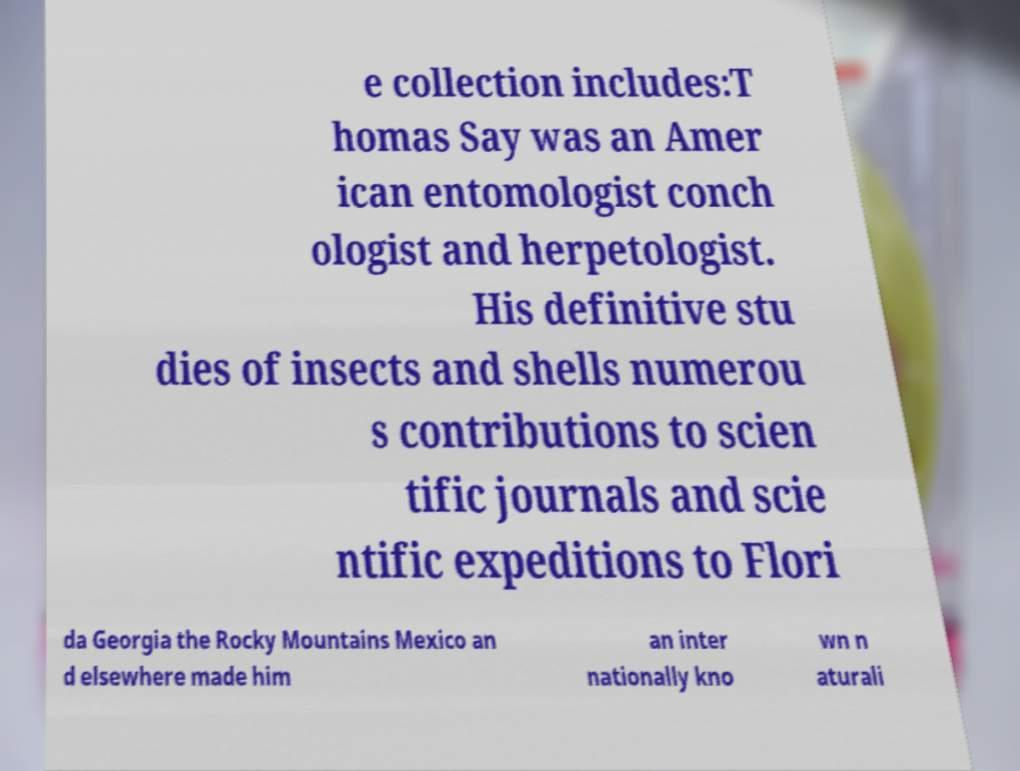Please identify and transcribe the text found in this image. e collection includes:T homas Say was an Amer ican entomologist conch ologist and herpetologist. His definitive stu dies of insects and shells numerou s contributions to scien tific journals and scie ntific expeditions to Flori da Georgia the Rocky Mountains Mexico an d elsewhere made him an inter nationally kno wn n aturali 